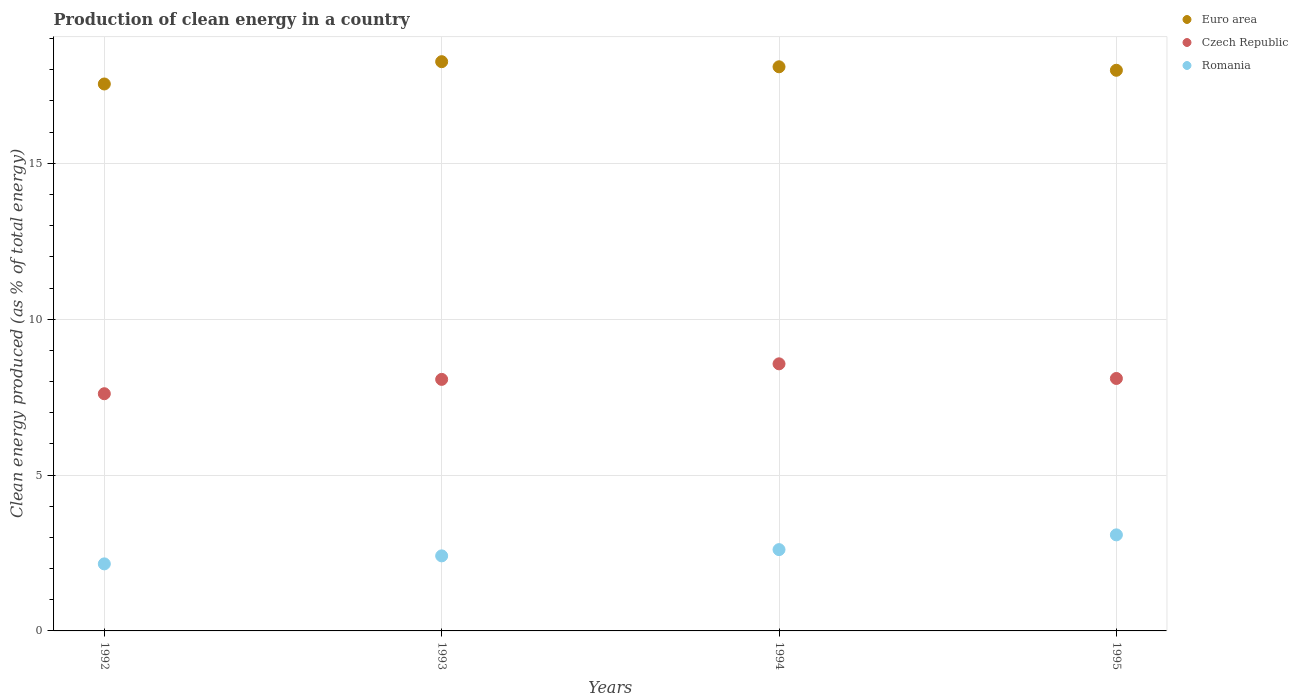How many different coloured dotlines are there?
Keep it short and to the point. 3. What is the percentage of clean energy produced in Euro area in 1992?
Make the answer very short. 17.54. Across all years, what is the maximum percentage of clean energy produced in Euro area?
Offer a very short reply. 18.26. Across all years, what is the minimum percentage of clean energy produced in Czech Republic?
Keep it short and to the point. 7.61. What is the total percentage of clean energy produced in Czech Republic in the graph?
Your answer should be compact. 32.34. What is the difference between the percentage of clean energy produced in Czech Republic in 1993 and that in 1994?
Make the answer very short. -0.5. What is the difference between the percentage of clean energy produced in Euro area in 1994 and the percentage of clean energy produced in Czech Republic in 1995?
Make the answer very short. 10. What is the average percentage of clean energy produced in Euro area per year?
Give a very brief answer. 17.97. In the year 1995, what is the difference between the percentage of clean energy produced in Czech Republic and percentage of clean energy produced in Romania?
Offer a terse response. 5.02. In how many years, is the percentage of clean energy produced in Euro area greater than 9 %?
Ensure brevity in your answer.  4. What is the ratio of the percentage of clean energy produced in Czech Republic in 1993 to that in 1995?
Your answer should be very brief. 1. What is the difference between the highest and the second highest percentage of clean energy produced in Euro area?
Offer a very short reply. 0.16. What is the difference between the highest and the lowest percentage of clean energy produced in Euro area?
Provide a short and direct response. 0.72. Is the sum of the percentage of clean energy produced in Czech Republic in 1992 and 1993 greater than the maximum percentage of clean energy produced in Euro area across all years?
Provide a short and direct response. No. What is the difference between two consecutive major ticks on the Y-axis?
Give a very brief answer. 5. Does the graph contain any zero values?
Offer a very short reply. No. Where does the legend appear in the graph?
Keep it short and to the point. Top right. What is the title of the graph?
Keep it short and to the point. Production of clean energy in a country. What is the label or title of the X-axis?
Your response must be concise. Years. What is the label or title of the Y-axis?
Your answer should be very brief. Clean energy produced (as % of total energy). What is the Clean energy produced (as % of total energy) of Euro area in 1992?
Make the answer very short. 17.54. What is the Clean energy produced (as % of total energy) in Czech Republic in 1992?
Your answer should be compact. 7.61. What is the Clean energy produced (as % of total energy) of Romania in 1992?
Your answer should be very brief. 2.15. What is the Clean energy produced (as % of total energy) of Euro area in 1993?
Ensure brevity in your answer.  18.26. What is the Clean energy produced (as % of total energy) of Czech Republic in 1993?
Provide a short and direct response. 8.07. What is the Clean energy produced (as % of total energy) of Romania in 1993?
Your answer should be very brief. 2.41. What is the Clean energy produced (as % of total energy) of Euro area in 1994?
Offer a very short reply. 18.1. What is the Clean energy produced (as % of total energy) in Czech Republic in 1994?
Provide a short and direct response. 8.57. What is the Clean energy produced (as % of total energy) of Romania in 1994?
Provide a short and direct response. 2.61. What is the Clean energy produced (as % of total energy) of Euro area in 1995?
Offer a very short reply. 17.98. What is the Clean energy produced (as % of total energy) in Czech Republic in 1995?
Provide a succinct answer. 8.1. What is the Clean energy produced (as % of total energy) in Romania in 1995?
Your response must be concise. 3.08. Across all years, what is the maximum Clean energy produced (as % of total energy) in Euro area?
Give a very brief answer. 18.26. Across all years, what is the maximum Clean energy produced (as % of total energy) of Czech Republic?
Offer a very short reply. 8.57. Across all years, what is the maximum Clean energy produced (as % of total energy) of Romania?
Your answer should be very brief. 3.08. Across all years, what is the minimum Clean energy produced (as % of total energy) of Euro area?
Provide a succinct answer. 17.54. Across all years, what is the minimum Clean energy produced (as % of total energy) in Czech Republic?
Make the answer very short. 7.61. Across all years, what is the minimum Clean energy produced (as % of total energy) of Romania?
Your answer should be compact. 2.15. What is the total Clean energy produced (as % of total energy) of Euro area in the graph?
Your response must be concise. 71.88. What is the total Clean energy produced (as % of total energy) in Czech Republic in the graph?
Provide a short and direct response. 32.34. What is the total Clean energy produced (as % of total energy) of Romania in the graph?
Make the answer very short. 10.25. What is the difference between the Clean energy produced (as % of total energy) of Euro area in 1992 and that in 1993?
Provide a succinct answer. -0.72. What is the difference between the Clean energy produced (as % of total energy) of Czech Republic in 1992 and that in 1993?
Offer a very short reply. -0.46. What is the difference between the Clean energy produced (as % of total energy) in Romania in 1992 and that in 1993?
Your response must be concise. -0.26. What is the difference between the Clean energy produced (as % of total energy) in Euro area in 1992 and that in 1994?
Offer a terse response. -0.55. What is the difference between the Clean energy produced (as % of total energy) of Czech Republic in 1992 and that in 1994?
Make the answer very short. -0.96. What is the difference between the Clean energy produced (as % of total energy) in Romania in 1992 and that in 1994?
Offer a very short reply. -0.46. What is the difference between the Clean energy produced (as % of total energy) in Euro area in 1992 and that in 1995?
Give a very brief answer. -0.44. What is the difference between the Clean energy produced (as % of total energy) in Czech Republic in 1992 and that in 1995?
Keep it short and to the point. -0.49. What is the difference between the Clean energy produced (as % of total energy) in Romania in 1992 and that in 1995?
Your answer should be compact. -0.93. What is the difference between the Clean energy produced (as % of total energy) of Euro area in 1993 and that in 1994?
Provide a short and direct response. 0.16. What is the difference between the Clean energy produced (as % of total energy) of Czech Republic in 1993 and that in 1994?
Your answer should be compact. -0.5. What is the difference between the Clean energy produced (as % of total energy) of Romania in 1993 and that in 1994?
Your answer should be very brief. -0.2. What is the difference between the Clean energy produced (as % of total energy) of Euro area in 1993 and that in 1995?
Ensure brevity in your answer.  0.28. What is the difference between the Clean energy produced (as % of total energy) of Czech Republic in 1993 and that in 1995?
Your answer should be compact. -0.03. What is the difference between the Clean energy produced (as % of total energy) in Romania in 1993 and that in 1995?
Your answer should be compact. -0.67. What is the difference between the Clean energy produced (as % of total energy) of Euro area in 1994 and that in 1995?
Offer a very short reply. 0.11. What is the difference between the Clean energy produced (as % of total energy) of Czech Republic in 1994 and that in 1995?
Make the answer very short. 0.47. What is the difference between the Clean energy produced (as % of total energy) of Romania in 1994 and that in 1995?
Offer a very short reply. -0.47. What is the difference between the Clean energy produced (as % of total energy) of Euro area in 1992 and the Clean energy produced (as % of total energy) of Czech Republic in 1993?
Make the answer very short. 9.48. What is the difference between the Clean energy produced (as % of total energy) in Euro area in 1992 and the Clean energy produced (as % of total energy) in Romania in 1993?
Your response must be concise. 15.14. What is the difference between the Clean energy produced (as % of total energy) in Czech Republic in 1992 and the Clean energy produced (as % of total energy) in Romania in 1993?
Your answer should be compact. 5.2. What is the difference between the Clean energy produced (as % of total energy) in Euro area in 1992 and the Clean energy produced (as % of total energy) in Czech Republic in 1994?
Offer a terse response. 8.98. What is the difference between the Clean energy produced (as % of total energy) of Euro area in 1992 and the Clean energy produced (as % of total energy) of Romania in 1994?
Ensure brevity in your answer.  14.94. What is the difference between the Clean energy produced (as % of total energy) in Czech Republic in 1992 and the Clean energy produced (as % of total energy) in Romania in 1994?
Provide a short and direct response. 5. What is the difference between the Clean energy produced (as % of total energy) in Euro area in 1992 and the Clean energy produced (as % of total energy) in Czech Republic in 1995?
Give a very brief answer. 9.45. What is the difference between the Clean energy produced (as % of total energy) of Euro area in 1992 and the Clean energy produced (as % of total energy) of Romania in 1995?
Offer a very short reply. 14.46. What is the difference between the Clean energy produced (as % of total energy) in Czech Republic in 1992 and the Clean energy produced (as % of total energy) in Romania in 1995?
Your answer should be compact. 4.53. What is the difference between the Clean energy produced (as % of total energy) in Euro area in 1993 and the Clean energy produced (as % of total energy) in Czech Republic in 1994?
Provide a short and direct response. 9.69. What is the difference between the Clean energy produced (as % of total energy) in Euro area in 1993 and the Clean energy produced (as % of total energy) in Romania in 1994?
Your answer should be very brief. 15.65. What is the difference between the Clean energy produced (as % of total energy) of Czech Republic in 1993 and the Clean energy produced (as % of total energy) of Romania in 1994?
Your response must be concise. 5.46. What is the difference between the Clean energy produced (as % of total energy) in Euro area in 1993 and the Clean energy produced (as % of total energy) in Czech Republic in 1995?
Your answer should be compact. 10.16. What is the difference between the Clean energy produced (as % of total energy) in Euro area in 1993 and the Clean energy produced (as % of total energy) in Romania in 1995?
Give a very brief answer. 15.18. What is the difference between the Clean energy produced (as % of total energy) of Czech Republic in 1993 and the Clean energy produced (as % of total energy) of Romania in 1995?
Offer a terse response. 4.99. What is the difference between the Clean energy produced (as % of total energy) in Euro area in 1994 and the Clean energy produced (as % of total energy) in Czech Republic in 1995?
Offer a terse response. 10. What is the difference between the Clean energy produced (as % of total energy) of Euro area in 1994 and the Clean energy produced (as % of total energy) of Romania in 1995?
Give a very brief answer. 15.01. What is the difference between the Clean energy produced (as % of total energy) of Czech Republic in 1994 and the Clean energy produced (as % of total energy) of Romania in 1995?
Make the answer very short. 5.49. What is the average Clean energy produced (as % of total energy) of Euro area per year?
Offer a terse response. 17.97. What is the average Clean energy produced (as % of total energy) in Czech Republic per year?
Provide a short and direct response. 8.09. What is the average Clean energy produced (as % of total energy) in Romania per year?
Ensure brevity in your answer.  2.56. In the year 1992, what is the difference between the Clean energy produced (as % of total energy) of Euro area and Clean energy produced (as % of total energy) of Czech Republic?
Offer a terse response. 9.94. In the year 1992, what is the difference between the Clean energy produced (as % of total energy) in Euro area and Clean energy produced (as % of total energy) in Romania?
Keep it short and to the point. 15.39. In the year 1992, what is the difference between the Clean energy produced (as % of total energy) in Czech Republic and Clean energy produced (as % of total energy) in Romania?
Make the answer very short. 5.46. In the year 1993, what is the difference between the Clean energy produced (as % of total energy) in Euro area and Clean energy produced (as % of total energy) in Czech Republic?
Your response must be concise. 10.19. In the year 1993, what is the difference between the Clean energy produced (as % of total energy) in Euro area and Clean energy produced (as % of total energy) in Romania?
Offer a terse response. 15.85. In the year 1993, what is the difference between the Clean energy produced (as % of total energy) in Czech Republic and Clean energy produced (as % of total energy) in Romania?
Make the answer very short. 5.66. In the year 1994, what is the difference between the Clean energy produced (as % of total energy) in Euro area and Clean energy produced (as % of total energy) in Czech Republic?
Provide a succinct answer. 9.53. In the year 1994, what is the difference between the Clean energy produced (as % of total energy) of Euro area and Clean energy produced (as % of total energy) of Romania?
Offer a very short reply. 15.49. In the year 1994, what is the difference between the Clean energy produced (as % of total energy) of Czech Republic and Clean energy produced (as % of total energy) of Romania?
Your response must be concise. 5.96. In the year 1995, what is the difference between the Clean energy produced (as % of total energy) in Euro area and Clean energy produced (as % of total energy) in Czech Republic?
Your answer should be compact. 9.89. In the year 1995, what is the difference between the Clean energy produced (as % of total energy) in Euro area and Clean energy produced (as % of total energy) in Romania?
Make the answer very short. 14.9. In the year 1995, what is the difference between the Clean energy produced (as % of total energy) in Czech Republic and Clean energy produced (as % of total energy) in Romania?
Your answer should be compact. 5.02. What is the ratio of the Clean energy produced (as % of total energy) of Euro area in 1992 to that in 1993?
Offer a very short reply. 0.96. What is the ratio of the Clean energy produced (as % of total energy) of Czech Republic in 1992 to that in 1993?
Your answer should be compact. 0.94. What is the ratio of the Clean energy produced (as % of total energy) in Romania in 1992 to that in 1993?
Offer a terse response. 0.89. What is the ratio of the Clean energy produced (as % of total energy) of Euro area in 1992 to that in 1994?
Offer a very short reply. 0.97. What is the ratio of the Clean energy produced (as % of total energy) of Czech Republic in 1992 to that in 1994?
Ensure brevity in your answer.  0.89. What is the ratio of the Clean energy produced (as % of total energy) of Romania in 1992 to that in 1994?
Your answer should be compact. 0.82. What is the ratio of the Clean energy produced (as % of total energy) of Euro area in 1992 to that in 1995?
Provide a succinct answer. 0.98. What is the ratio of the Clean energy produced (as % of total energy) in Czech Republic in 1992 to that in 1995?
Your answer should be compact. 0.94. What is the ratio of the Clean energy produced (as % of total energy) of Romania in 1992 to that in 1995?
Make the answer very short. 0.7. What is the ratio of the Clean energy produced (as % of total energy) of Euro area in 1993 to that in 1994?
Give a very brief answer. 1.01. What is the ratio of the Clean energy produced (as % of total energy) of Czech Republic in 1993 to that in 1994?
Ensure brevity in your answer.  0.94. What is the ratio of the Clean energy produced (as % of total energy) of Euro area in 1993 to that in 1995?
Your answer should be compact. 1.02. What is the ratio of the Clean energy produced (as % of total energy) in Romania in 1993 to that in 1995?
Give a very brief answer. 0.78. What is the ratio of the Clean energy produced (as % of total energy) in Euro area in 1994 to that in 1995?
Provide a short and direct response. 1.01. What is the ratio of the Clean energy produced (as % of total energy) in Czech Republic in 1994 to that in 1995?
Provide a succinct answer. 1.06. What is the ratio of the Clean energy produced (as % of total energy) in Romania in 1994 to that in 1995?
Ensure brevity in your answer.  0.85. What is the difference between the highest and the second highest Clean energy produced (as % of total energy) of Euro area?
Your answer should be compact. 0.16. What is the difference between the highest and the second highest Clean energy produced (as % of total energy) of Czech Republic?
Ensure brevity in your answer.  0.47. What is the difference between the highest and the second highest Clean energy produced (as % of total energy) in Romania?
Give a very brief answer. 0.47. What is the difference between the highest and the lowest Clean energy produced (as % of total energy) of Euro area?
Your response must be concise. 0.72. What is the difference between the highest and the lowest Clean energy produced (as % of total energy) of Czech Republic?
Provide a short and direct response. 0.96. What is the difference between the highest and the lowest Clean energy produced (as % of total energy) of Romania?
Your response must be concise. 0.93. 